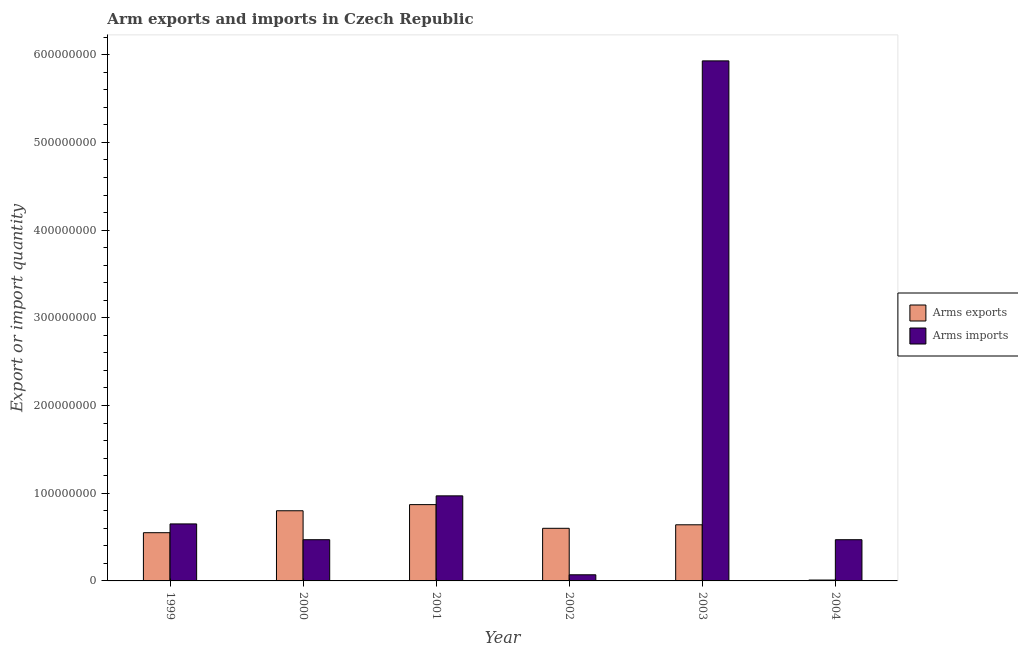How many groups of bars are there?
Provide a succinct answer. 6. Are the number of bars on each tick of the X-axis equal?
Your answer should be compact. Yes. How many bars are there on the 1st tick from the right?
Provide a short and direct response. 2. In how many cases, is the number of bars for a given year not equal to the number of legend labels?
Keep it short and to the point. 0. What is the arms imports in 2000?
Your response must be concise. 4.70e+07. Across all years, what is the maximum arms exports?
Your answer should be compact. 8.70e+07. Across all years, what is the minimum arms imports?
Your response must be concise. 7.00e+06. In which year was the arms exports minimum?
Offer a very short reply. 2004. What is the total arms exports in the graph?
Your response must be concise. 3.47e+08. What is the difference between the arms exports in 1999 and that in 2003?
Offer a very short reply. -9.00e+06. What is the difference between the arms exports in 2000 and the arms imports in 2003?
Your answer should be very brief. 1.60e+07. What is the average arms exports per year?
Provide a short and direct response. 5.78e+07. In the year 1999, what is the difference between the arms imports and arms exports?
Your response must be concise. 0. In how many years, is the arms imports greater than 60000000?
Your answer should be compact. 3. What is the ratio of the arms imports in 2000 to that in 2001?
Offer a very short reply. 0.48. Is the difference between the arms exports in 2001 and 2003 greater than the difference between the arms imports in 2001 and 2003?
Your response must be concise. No. What is the difference between the highest and the second highest arms exports?
Provide a succinct answer. 7.00e+06. What is the difference between the highest and the lowest arms imports?
Your response must be concise. 5.86e+08. In how many years, is the arms imports greater than the average arms imports taken over all years?
Your answer should be compact. 1. What does the 1st bar from the left in 1999 represents?
Keep it short and to the point. Arms exports. What does the 2nd bar from the right in 2000 represents?
Your answer should be compact. Arms exports. How many bars are there?
Offer a very short reply. 12. How many years are there in the graph?
Keep it short and to the point. 6. What is the difference between two consecutive major ticks on the Y-axis?
Your answer should be compact. 1.00e+08. Are the values on the major ticks of Y-axis written in scientific E-notation?
Give a very brief answer. No. Does the graph contain grids?
Offer a very short reply. No. Where does the legend appear in the graph?
Offer a terse response. Center right. How many legend labels are there?
Your answer should be very brief. 2. What is the title of the graph?
Offer a terse response. Arm exports and imports in Czech Republic. What is the label or title of the X-axis?
Make the answer very short. Year. What is the label or title of the Y-axis?
Provide a succinct answer. Export or import quantity. What is the Export or import quantity in Arms exports in 1999?
Keep it short and to the point. 5.50e+07. What is the Export or import quantity in Arms imports in 1999?
Your answer should be very brief. 6.50e+07. What is the Export or import quantity in Arms exports in 2000?
Keep it short and to the point. 8.00e+07. What is the Export or import quantity in Arms imports in 2000?
Offer a very short reply. 4.70e+07. What is the Export or import quantity of Arms exports in 2001?
Make the answer very short. 8.70e+07. What is the Export or import quantity in Arms imports in 2001?
Your answer should be very brief. 9.70e+07. What is the Export or import quantity of Arms exports in 2002?
Give a very brief answer. 6.00e+07. What is the Export or import quantity in Arms exports in 2003?
Offer a very short reply. 6.40e+07. What is the Export or import quantity of Arms imports in 2003?
Provide a succinct answer. 5.93e+08. What is the Export or import quantity in Arms imports in 2004?
Make the answer very short. 4.70e+07. Across all years, what is the maximum Export or import quantity of Arms exports?
Your answer should be compact. 8.70e+07. Across all years, what is the maximum Export or import quantity of Arms imports?
Your answer should be compact. 5.93e+08. Across all years, what is the minimum Export or import quantity of Arms imports?
Ensure brevity in your answer.  7.00e+06. What is the total Export or import quantity in Arms exports in the graph?
Ensure brevity in your answer.  3.47e+08. What is the total Export or import quantity of Arms imports in the graph?
Your response must be concise. 8.56e+08. What is the difference between the Export or import quantity of Arms exports in 1999 and that in 2000?
Provide a short and direct response. -2.50e+07. What is the difference between the Export or import quantity in Arms imports in 1999 and that in 2000?
Provide a short and direct response. 1.80e+07. What is the difference between the Export or import quantity in Arms exports in 1999 and that in 2001?
Give a very brief answer. -3.20e+07. What is the difference between the Export or import quantity of Arms imports in 1999 and that in 2001?
Keep it short and to the point. -3.20e+07. What is the difference between the Export or import quantity of Arms exports in 1999 and that in 2002?
Your answer should be very brief. -5.00e+06. What is the difference between the Export or import quantity of Arms imports in 1999 and that in 2002?
Provide a succinct answer. 5.80e+07. What is the difference between the Export or import quantity of Arms exports in 1999 and that in 2003?
Provide a succinct answer. -9.00e+06. What is the difference between the Export or import quantity of Arms imports in 1999 and that in 2003?
Your answer should be very brief. -5.28e+08. What is the difference between the Export or import quantity in Arms exports in 1999 and that in 2004?
Your answer should be very brief. 5.40e+07. What is the difference between the Export or import quantity of Arms imports in 1999 and that in 2004?
Provide a succinct answer. 1.80e+07. What is the difference between the Export or import quantity in Arms exports in 2000 and that in 2001?
Make the answer very short. -7.00e+06. What is the difference between the Export or import quantity in Arms imports in 2000 and that in 2001?
Offer a terse response. -5.00e+07. What is the difference between the Export or import quantity in Arms imports in 2000 and that in 2002?
Offer a terse response. 4.00e+07. What is the difference between the Export or import quantity of Arms exports in 2000 and that in 2003?
Your answer should be compact. 1.60e+07. What is the difference between the Export or import quantity of Arms imports in 2000 and that in 2003?
Keep it short and to the point. -5.46e+08. What is the difference between the Export or import quantity of Arms exports in 2000 and that in 2004?
Your answer should be very brief. 7.90e+07. What is the difference between the Export or import quantity in Arms imports in 2000 and that in 2004?
Your response must be concise. 0. What is the difference between the Export or import quantity in Arms exports in 2001 and that in 2002?
Your answer should be very brief. 2.70e+07. What is the difference between the Export or import quantity in Arms imports in 2001 and that in 2002?
Keep it short and to the point. 9.00e+07. What is the difference between the Export or import quantity of Arms exports in 2001 and that in 2003?
Offer a terse response. 2.30e+07. What is the difference between the Export or import quantity of Arms imports in 2001 and that in 2003?
Keep it short and to the point. -4.96e+08. What is the difference between the Export or import quantity of Arms exports in 2001 and that in 2004?
Your response must be concise. 8.60e+07. What is the difference between the Export or import quantity of Arms imports in 2001 and that in 2004?
Offer a terse response. 5.00e+07. What is the difference between the Export or import quantity of Arms imports in 2002 and that in 2003?
Your answer should be very brief. -5.86e+08. What is the difference between the Export or import quantity of Arms exports in 2002 and that in 2004?
Make the answer very short. 5.90e+07. What is the difference between the Export or import quantity in Arms imports in 2002 and that in 2004?
Your answer should be very brief. -4.00e+07. What is the difference between the Export or import quantity of Arms exports in 2003 and that in 2004?
Provide a short and direct response. 6.30e+07. What is the difference between the Export or import quantity in Arms imports in 2003 and that in 2004?
Your answer should be very brief. 5.46e+08. What is the difference between the Export or import quantity in Arms exports in 1999 and the Export or import quantity in Arms imports in 2001?
Your answer should be very brief. -4.20e+07. What is the difference between the Export or import quantity in Arms exports in 1999 and the Export or import quantity in Arms imports in 2002?
Ensure brevity in your answer.  4.80e+07. What is the difference between the Export or import quantity of Arms exports in 1999 and the Export or import quantity of Arms imports in 2003?
Provide a succinct answer. -5.38e+08. What is the difference between the Export or import quantity in Arms exports in 1999 and the Export or import quantity in Arms imports in 2004?
Your answer should be compact. 8.00e+06. What is the difference between the Export or import quantity of Arms exports in 2000 and the Export or import quantity of Arms imports in 2001?
Make the answer very short. -1.70e+07. What is the difference between the Export or import quantity in Arms exports in 2000 and the Export or import quantity in Arms imports in 2002?
Provide a short and direct response. 7.30e+07. What is the difference between the Export or import quantity of Arms exports in 2000 and the Export or import quantity of Arms imports in 2003?
Provide a short and direct response. -5.13e+08. What is the difference between the Export or import quantity in Arms exports in 2000 and the Export or import quantity in Arms imports in 2004?
Provide a short and direct response. 3.30e+07. What is the difference between the Export or import quantity in Arms exports in 2001 and the Export or import quantity in Arms imports in 2002?
Keep it short and to the point. 8.00e+07. What is the difference between the Export or import quantity of Arms exports in 2001 and the Export or import quantity of Arms imports in 2003?
Give a very brief answer. -5.06e+08. What is the difference between the Export or import quantity of Arms exports in 2001 and the Export or import quantity of Arms imports in 2004?
Your answer should be very brief. 4.00e+07. What is the difference between the Export or import quantity in Arms exports in 2002 and the Export or import quantity in Arms imports in 2003?
Make the answer very short. -5.33e+08. What is the difference between the Export or import quantity in Arms exports in 2002 and the Export or import quantity in Arms imports in 2004?
Ensure brevity in your answer.  1.30e+07. What is the difference between the Export or import quantity in Arms exports in 2003 and the Export or import quantity in Arms imports in 2004?
Give a very brief answer. 1.70e+07. What is the average Export or import quantity of Arms exports per year?
Your answer should be very brief. 5.78e+07. What is the average Export or import quantity in Arms imports per year?
Give a very brief answer. 1.43e+08. In the year 1999, what is the difference between the Export or import quantity in Arms exports and Export or import quantity in Arms imports?
Ensure brevity in your answer.  -1.00e+07. In the year 2000, what is the difference between the Export or import quantity in Arms exports and Export or import quantity in Arms imports?
Provide a short and direct response. 3.30e+07. In the year 2001, what is the difference between the Export or import quantity of Arms exports and Export or import quantity of Arms imports?
Keep it short and to the point. -1.00e+07. In the year 2002, what is the difference between the Export or import quantity of Arms exports and Export or import quantity of Arms imports?
Your answer should be compact. 5.30e+07. In the year 2003, what is the difference between the Export or import quantity of Arms exports and Export or import quantity of Arms imports?
Provide a succinct answer. -5.29e+08. In the year 2004, what is the difference between the Export or import quantity in Arms exports and Export or import quantity in Arms imports?
Keep it short and to the point. -4.60e+07. What is the ratio of the Export or import quantity in Arms exports in 1999 to that in 2000?
Your response must be concise. 0.69. What is the ratio of the Export or import quantity of Arms imports in 1999 to that in 2000?
Provide a succinct answer. 1.38. What is the ratio of the Export or import quantity of Arms exports in 1999 to that in 2001?
Provide a short and direct response. 0.63. What is the ratio of the Export or import quantity in Arms imports in 1999 to that in 2001?
Provide a short and direct response. 0.67. What is the ratio of the Export or import quantity in Arms exports in 1999 to that in 2002?
Your response must be concise. 0.92. What is the ratio of the Export or import quantity in Arms imports in 1999 to that in 2002?
Offer a very short reply. 9.29. What is the ratio of the Export or import quantity of Arms exports in 1999 to that in 2003?
Provide a succinct answer. 0.86. What is the ratio of the Export or import quantity of Arms imports in 1999 to that in 2003?
Offer a terse response. 0.11. What is the ratio of the Export or import quantity in Arms imports in 1999 to that in 2004?
Your answer should be compact. 1.38. What is the ratio of the Export or import quantity of Arms exports in 2000 to that in 2001?
Make the answer very short. 0.92. What is the ratio of the Export or import quantity of Arms imports in 2000 to that in 2001?
Make the answer very short. 0.48. What is the ratio of the Export or import quantity of Arms imports in 2000 to that in 2002?
Keep it short and to the point. 6.71. What is the ratio of the Export or import quantity in Arms exports in 2000 to that in 2003?
Your answer should be compact. 1.25. What is the ratio of the Export or import quantity of Arms imports in 2000 to that in 2003?
Make the answer very short. 0.08. What is the ratio of the Export or import quantity of Arms exports in 2000 to that in 2004?
Offer a terse response. 80. What is the ratio of the Export or import quantity in Arms exports in 2001 to that in 2002?
Keep it short and to the point. 1.45. What is the ratio of the Export or import quantity in Arms imports in 2001 to that in 2002?
Keep it short and to the point. 13.86. What is the ratio of the Export or import quantity in Arms exports in 2001 to that in 2003?
Offer a terse response. 1.36. What is the ratio of the Export or import quantity of Arms imports in 2001 to that in 2003?
Your response must be concise. 0.16. What is the ratio of the Export or import quantity of Arms exports in 2001 to that in 2004?
Make the answer very short. 87. What is the ratio of the Export or import quantity of Arms imports in 2001 to that in 2004?
Make the answer very short. 2.06. What is the ratio of the Export or import quantity of Arms exports in 2002 to that in 2003?
Make the answer very short. 0.94. What is the ratio of the Export or import quantity of Arms imports in 2002 to that in 2003?
Your answer should be compact. 0.01. What is the ratio of the Export or import quantity in Arms imports in 2002 to that in 2004?
Provide a succinct answer. 0.15. What is the ratio of the Export or import quantity of Arms imports in 2003 to that in 2004?
Offer a very short reply. 12.62. What is the difference between the highest and the second highest Export or import quantity in Arms exports?
Ensure brevity in your answer.  7.00e+06. What is the difference between the highest and the second highest Export or import quantity in Arms imports?
Your response must be concise. 4.96e+08. What is the difference between the highest and the lowest Export or import quantity of Arms exports?
Offer a very short reply. 8.60e+07. What is the difference between the highest and the lowest Export or import quantity of Arms imports?
Offer a terse response. 5.86e+08. 